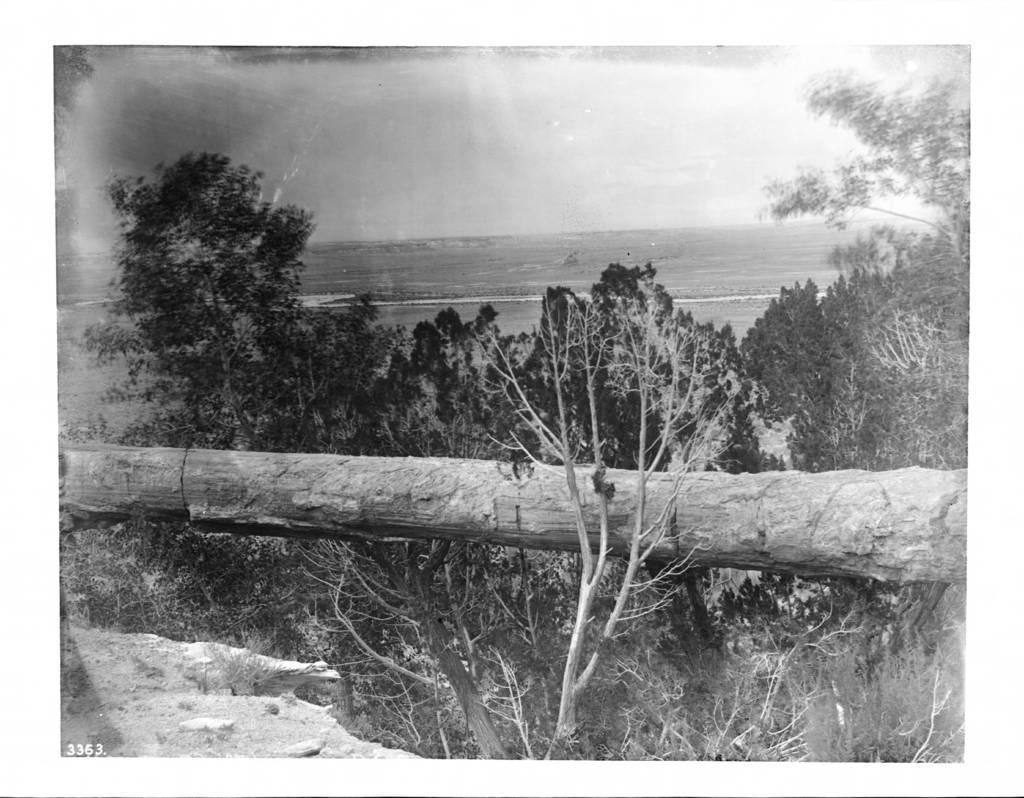Please provide a concise description of this image. This is a black and white image. In the middle of the image there is a tree trunk and many trees. In the bottom left-hand corner I can see the ground. At the top of the image I can see the sky. 